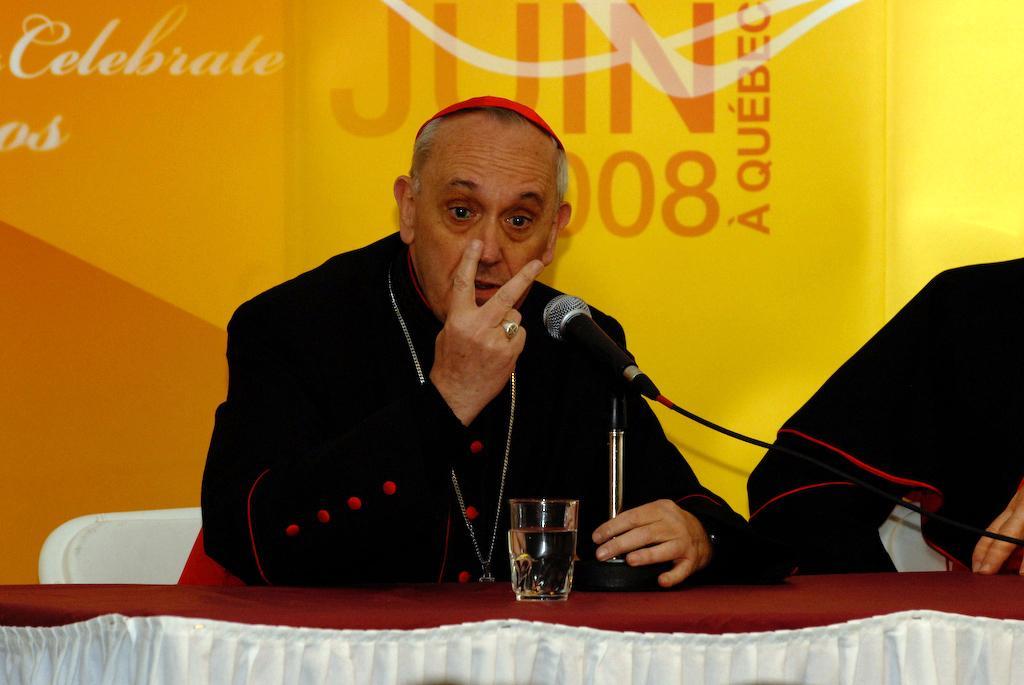How would you summarize this image in a sentence or two? In this image, we can can see people sitting on the chairs and one of them is wearing a chain and a cap and holding a mic stand and there is a glass with water is on the table. In the background, there is a board with some text. 